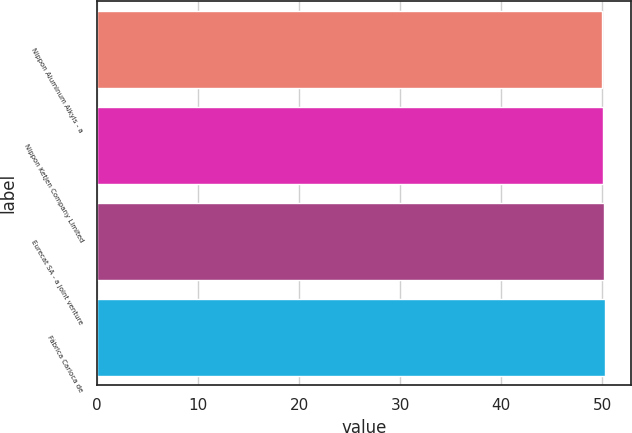Convert chart to OTSL. <chart><loc_0><loc_0><loc_500><loc_500><bar_chart><fcel>Nippon Aluminum Alkyls - a<fcel>Nippon Ketjen Company Limited<fcel>Eurecat SA - a joint venture<fcel>Fábrica Carioca de<nl><fcel>50<fcel>50.1<fcel>50.2<fcel>50.3<nl></chart> 